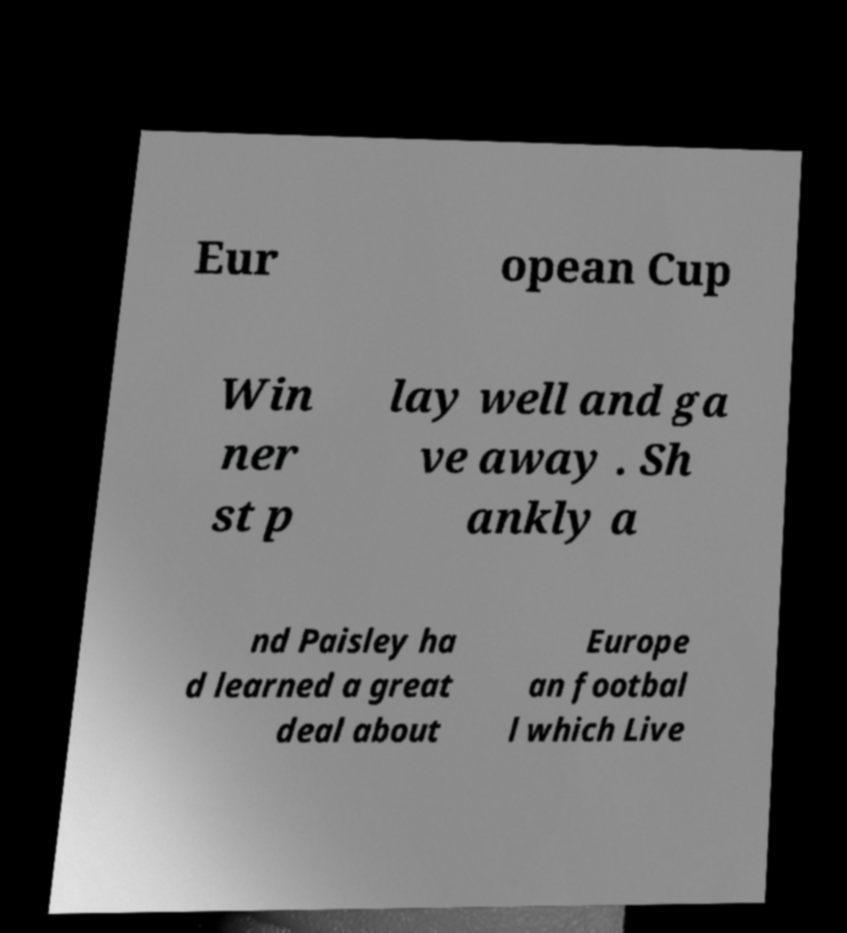There's text embedded in this image that I need extracted. Can you transcribe it verbatim? Eur opean Cup Win ner st p lay well and ga ve away . Sh ankly a nd Paisley ha d learned a great deal about Europe an footbal l which Live 